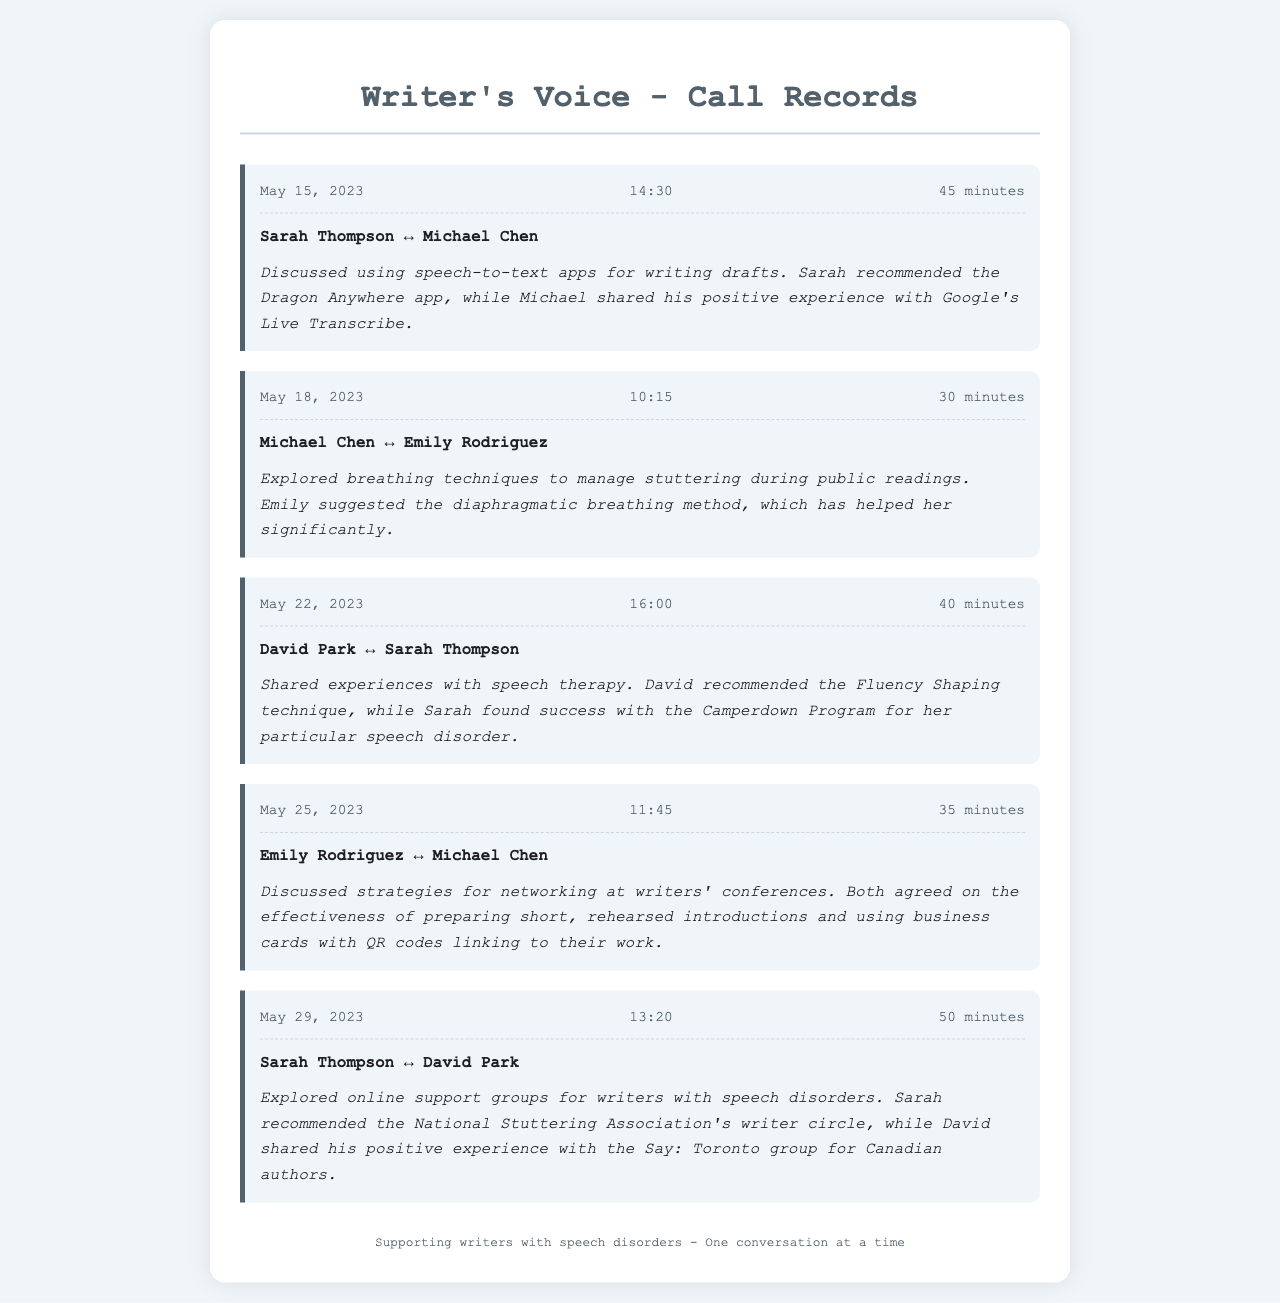what is the date of the call between Sarah Thompson and Michael Chen? The document states that the call occurred on May 15, 2023.
Answer: May 15, 2023 how long did the conversation between Michael Chen and Emily Rodriguez last? The duration of their call is indicated as 30 minutes.
Answer: 30 minutes which app did Sarah recommend during her call with Michael Chen? The document mentions that Sarah recommended the Dragon Anywhere app.
Answer: Dragon Anywhere who shared experiences with speech therapy with Sarah Thompson? The talk was shared with David Park, as indicated in their call record.
Answer: David Park what breathing technique did Emily suggest for managing stuttering? The document indicates that Emily suggested the diaphragmatic breathing method.
Answer: diaphragmatic breathing method how many calls are recorded in the document? To find this, count the number of individual call records, which totaled to five.
Answer: 5 what was discussed during the call between Sarah Thompson and David Park? They explored online support groups for writers with speech disorders in their conversation.
Answer: online support groups who had a positive experience with the Say: Toronto group? The conversation reveals that David shared his positive experience with this group.
Answer: David what two apps were mentioned for writing drafts? The document lists Dragon Anywhere and Google's Live Transcribe as mentioned apps.
Answer: Dragon Anywhere, Google's Live Transcribe 